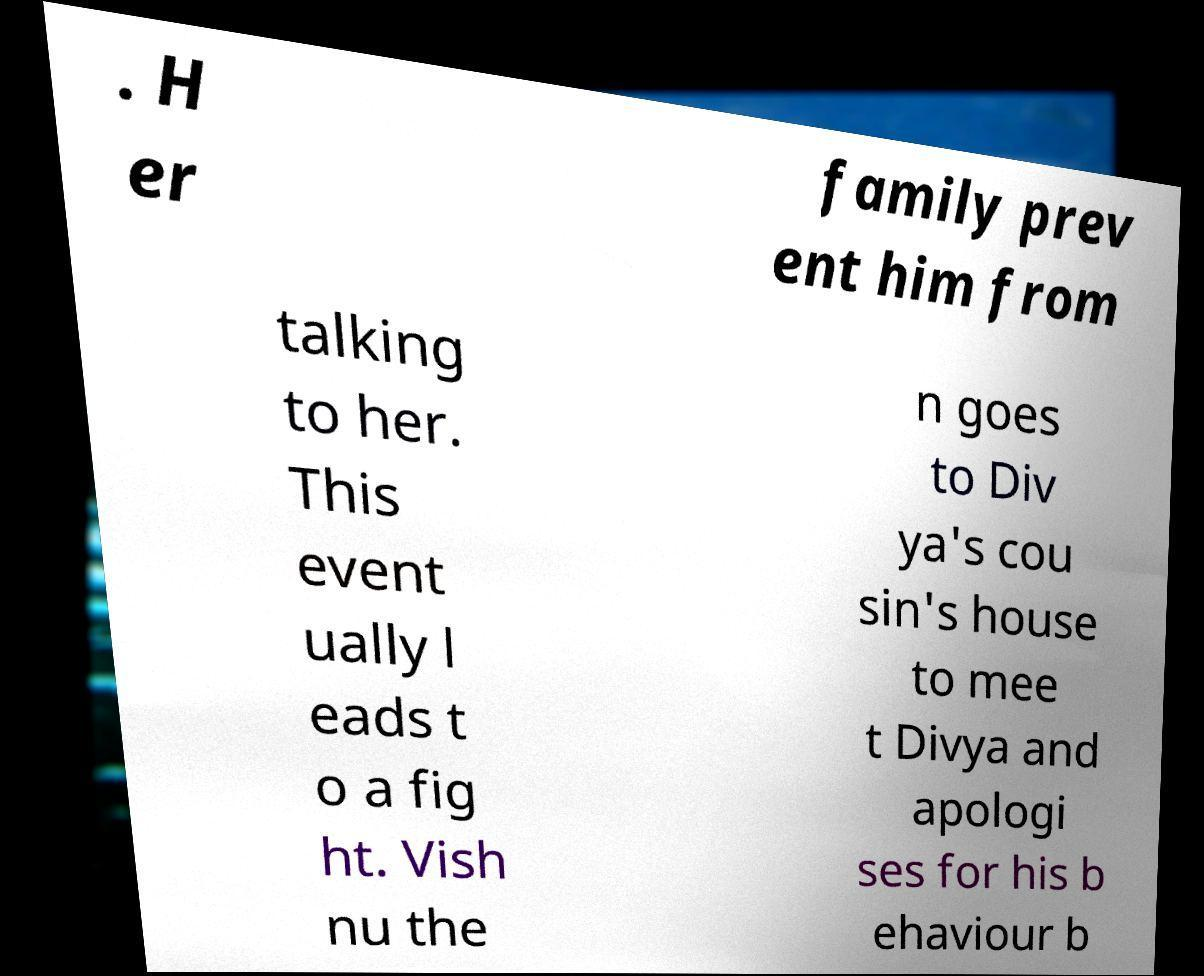What messages or text are displayed in this image? I need them in a readable, typed format. . H er family prev ent him from talking to her. This event ually l eads t o a fig ht. Vish nu the n goes to Div ya's cou sin's house to mee t Divya and apologi ses for his b ehaviour b 